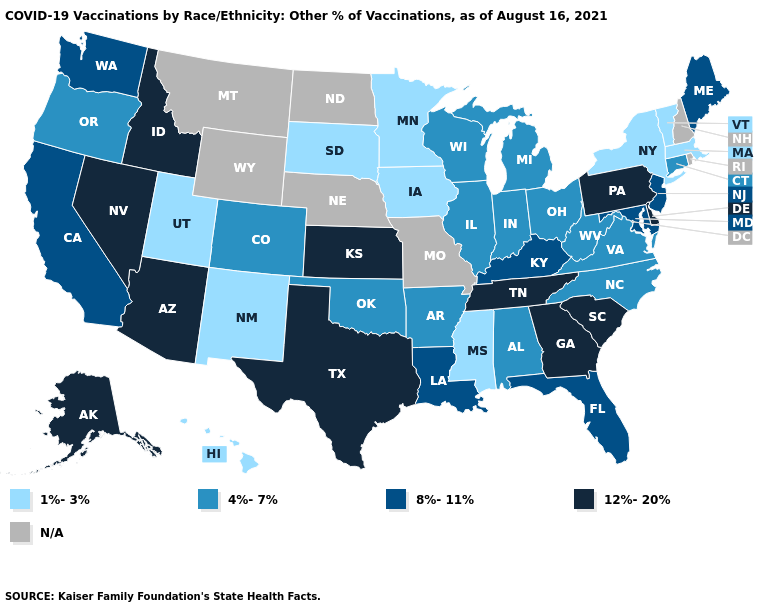Name the states that have a value in the range 1%-3%?
Answer briefly. Hawaii, Iowa, Massachusetts, Minnesota, Mississippi, New Mexico, New York, South Dakota, Utah, Vermont. What is the value of Vermont?
Short answer required. 1%-3%. Name the states that have a value in the range 4%-7%?
Be succinct. Alabama, Arkansas, Colorado, Connecticut, Illinois, Indiana, Michigan, North Carolina, Ohio, Oklahoma, Oregon, Virginia, West Virginia, Wisconsin. What is the lowest value in the USA?
Answer briefly. 1%-3%. Which states have the highest value in the USA?
Concise answer only. Alaska, Arizona, Delaware, Georgia, Idaho, Kansas, Nevada, Pennsylvania, South Carolina, Tennessee, Texas. What is the value of Connecticut?
Be succinct. 4%-7%. Does Arizona have the highest value in the West?
Short answer required. Yes. What is the highest value in the USA?
Quick response, please. 12%-20%. Does Wisconsin have the lowest value in the USA?
Give a very brief answer. No. Does South Dakota have the lowest value in the MidWest?
Be succinct. Yes. Name the states that have a value in the range 4%-7%?
Keep it brief. Alabama, Arkansas, Colorado, Connecticut, Illinois, Indiana, Michigan, North Carolina, Ohio, Oklahoma, Oregon, Virginia, West Virginia, Wisconsin. 